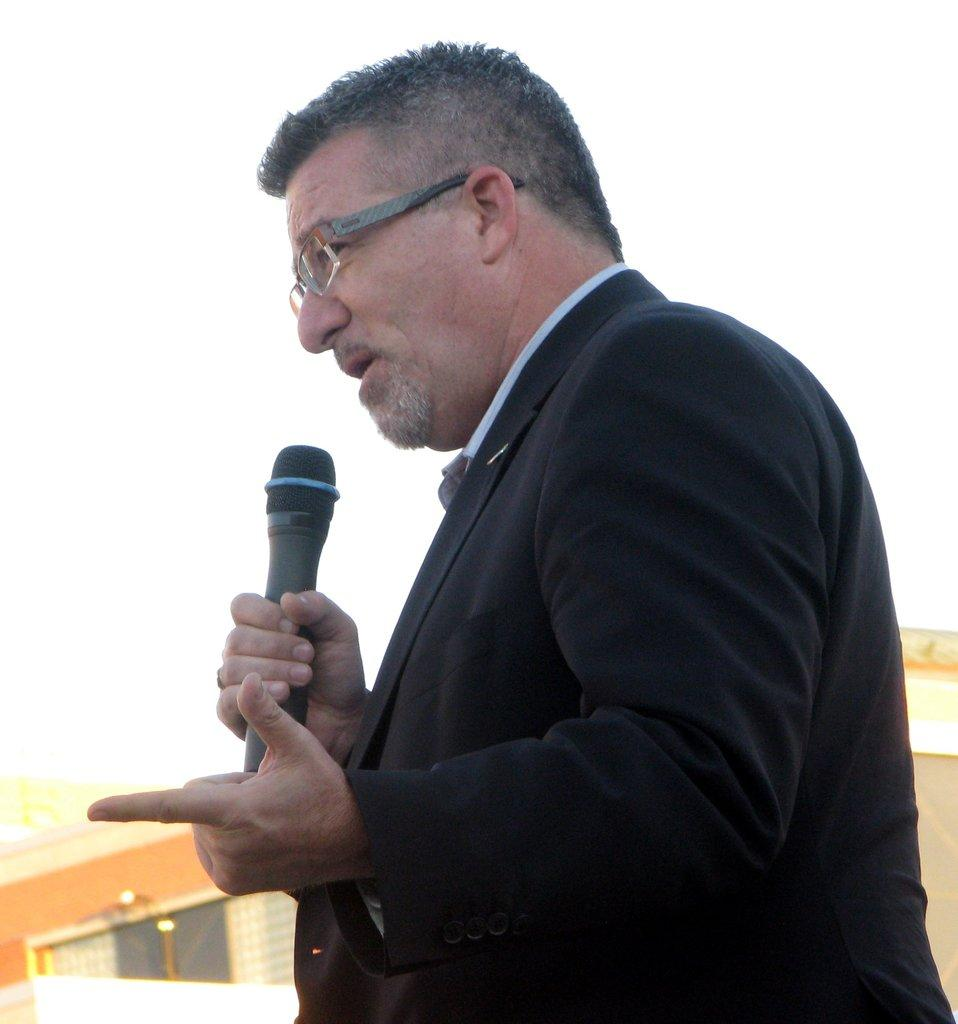What is the appearance of the man in the image? The man is wearing a black suit in the image. What is the man holding in the image? The man is holding a microphone in the image. What accessory is the man wearing in the image? The man is wearing spectacles in the image. What is the man doing in the image? The man is talking in the image. What type of squirrel can be seen regretting its scent in the image? There is no squirrel present in the image, and therefore no such activity can be observed. 